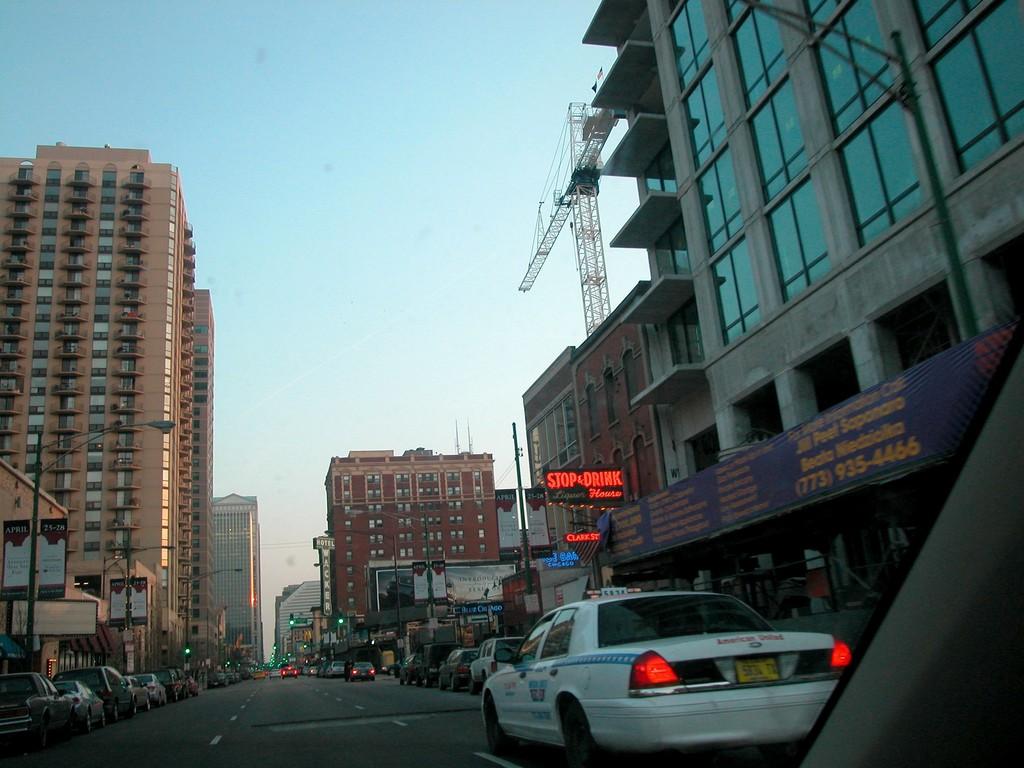What is scrolling on the electronic billboard?
Give a very brief answer. Stop & drink. What is the phone number above the white car?
Ensure brevity in your answer.  773-935-4466. 